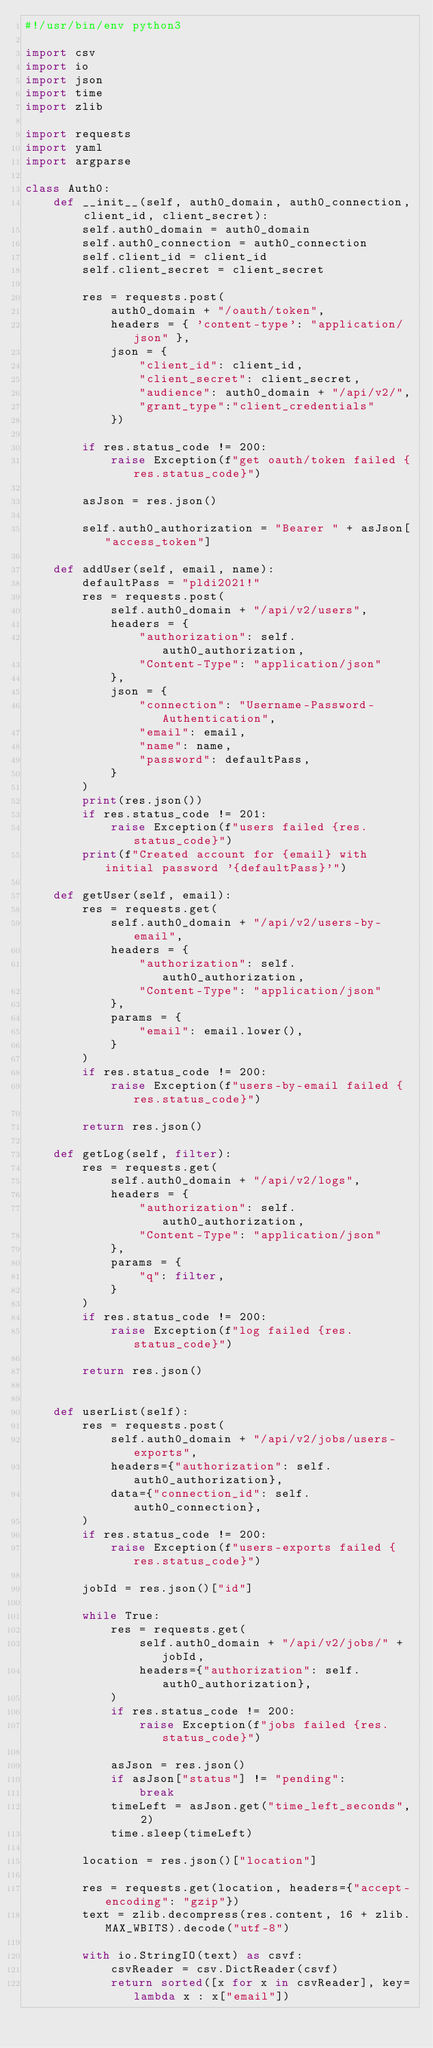Convert code to text. <code><loc_0><loc_0><loc_500><loc_500><_Python_>#!/usr/bin/env python3

import csv
import io
import json
import time
import zlib

import requests
import yaml
import argparse
 
class Auth0:
    def __init__(self, auth0_domain, auth0_connection, client_id, client_secret):
        self.auth0_domain = auth0_domain
        self.auth0_connection = auth0_connection
        self.client_id = client_id
        self.client_secret = client_secret

        res = requests.post(
            auth0_domain + "/oauth/token",
            headers = { 'content-type': "application/json" },
            json = {
                "client_id": client_id,
                "client_secret": client_secret,
                "audience": auth0_domain + "/api/v2/",
                "grant_type":"client_credentials"
            })

        if res.status_code != 200:
            raise Exception(f"get oauth/token failed {res.status_code}")

        asJson = res.json()

        self.auth0_authorization = "Bearer " + asJson["access_token"]

    def addUser(self, email, name):
        defaultPass = "pldi2021!"
        res = requests.post(
            self.auth0_domain + "/api/v2/users",
            headers = {
                "authorization": self.auth0_authorization,
                "Content-Type": "application/json"
            },
            json = {
                "connection": "Username-Password-Authentication", 
                "email": email,
                "name": name,
                "password": defaultPass,
            }
        )
        print(res.json())
        if res.status_code != 201:
            raise Exception(f"users failed {res.status_code}")
        print(f"Created account for {email} with initial password '{defaultPass}'")

    def getUser(self, email):
        res = requests.get(
            self.auth0_domain + "/api/v2/users-by-email",
            headers = {
                "authorization": self.auth0_authorization,
                "Content-Type": "application/json"
            },
            params = {
                "email": email.lower(),
            }
        )
        if res.status_code != 200:
            raise Exception(f"users-by-email failed {res.status_code}")

        return res.json()

    def getLog(self, filter):
        res = requests.get(
            self.auth0_domain + "/api/v2/logs",
            headers = {
                "authorization": self.auth0_authorization,
                "Content-Type": "application/json"
            },
            params = {
                "q": filter,
            }
        )
        if res.status_code != 200:
            raise Exception(f"log failed {res.status_code}")

        return res.json()


    def userList(self):
        res = requests.post(
            self.auth0_domain + "/api/v2/jobs/users-exports",
            headers={"authorization": self.auth0_authorization},
            data={"connection_id": self.auth0_connection},
        )
        if res.status_code != 200:
            raise Exception(f"users-exports failed {res.status_code}")

        jobId = res.json()["id"]

        while True:
            res = requests.get(
                self.auth0_domain + "/api/v2/jobs/" + jobId,
                headers={"authorization": self.auth0_authorization},
            )
            if res.status_code != 200:
                raise Exception(f"jobs failed {res.status_code}")

            asJson = res.json()
            if asJson["status"] != "pending":
                break
            timeLeft = asJson.get("time_left_seconds", 2)
            time.sleep(timeLeft)

        location = res.json()["location"]

        res = requests.get(location, headers={"accept-encoding": "gzip"})
        text = zlib.decompress(res.content, 16 + zlib.MAX_WBITS).decode("utf-8")

        with io.StringIO(text) as csvf:
            csvReader = csv.DictReader(csvf)
            return sorted([x for x in csvReader], key=lambda x : x["email"])

</code> 